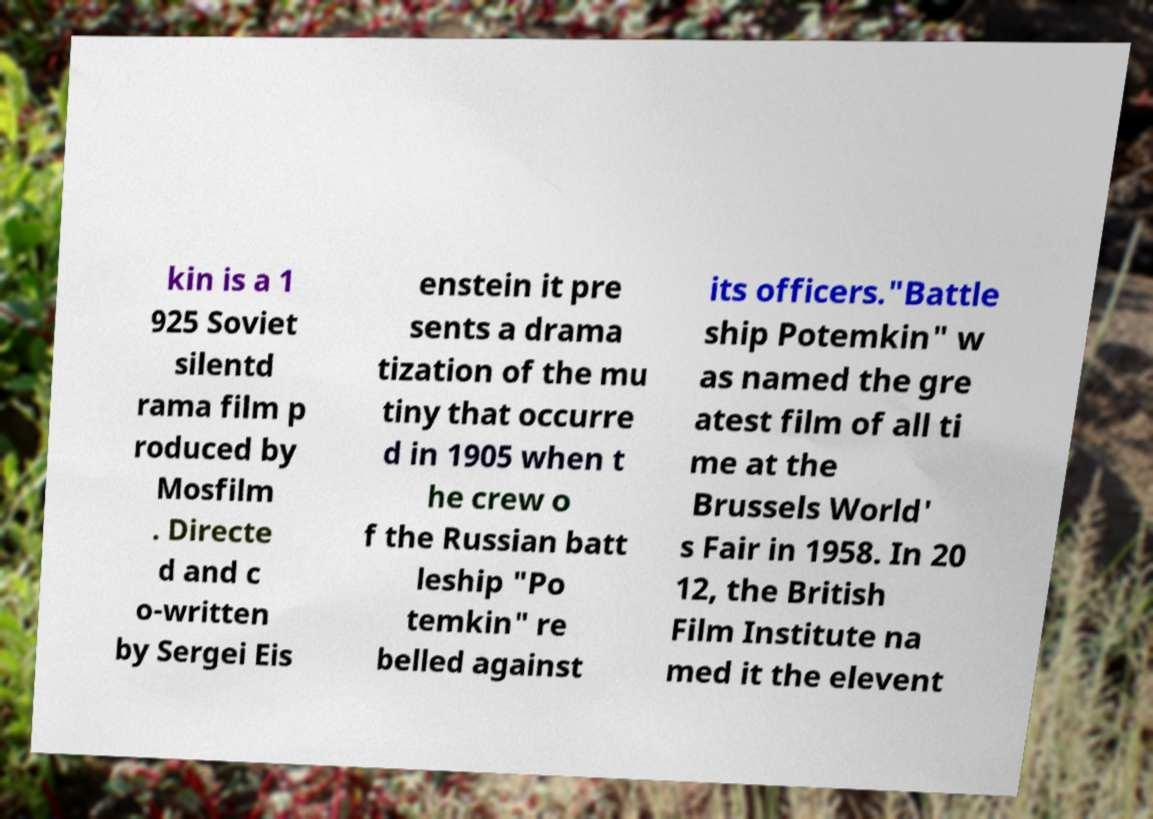Could you assist in decoding the text presented in this image and type it out clearly? kin is a 1 925 Soviet silentd rama film p roduced by Mosfilm . Directe d and c o-written by Sergei Eis enstein it pre sents a drama tization of the mu tiny that occurre d in 1905 when t he crew o f the Russian batt leship "Po temkin" re belled against its officers."Battle ship Potemkin" w as named the gre atest film of all ti me at the Brussels World' s Fair in 1958. In 20 12, the British Film Institute na med it the elevent 